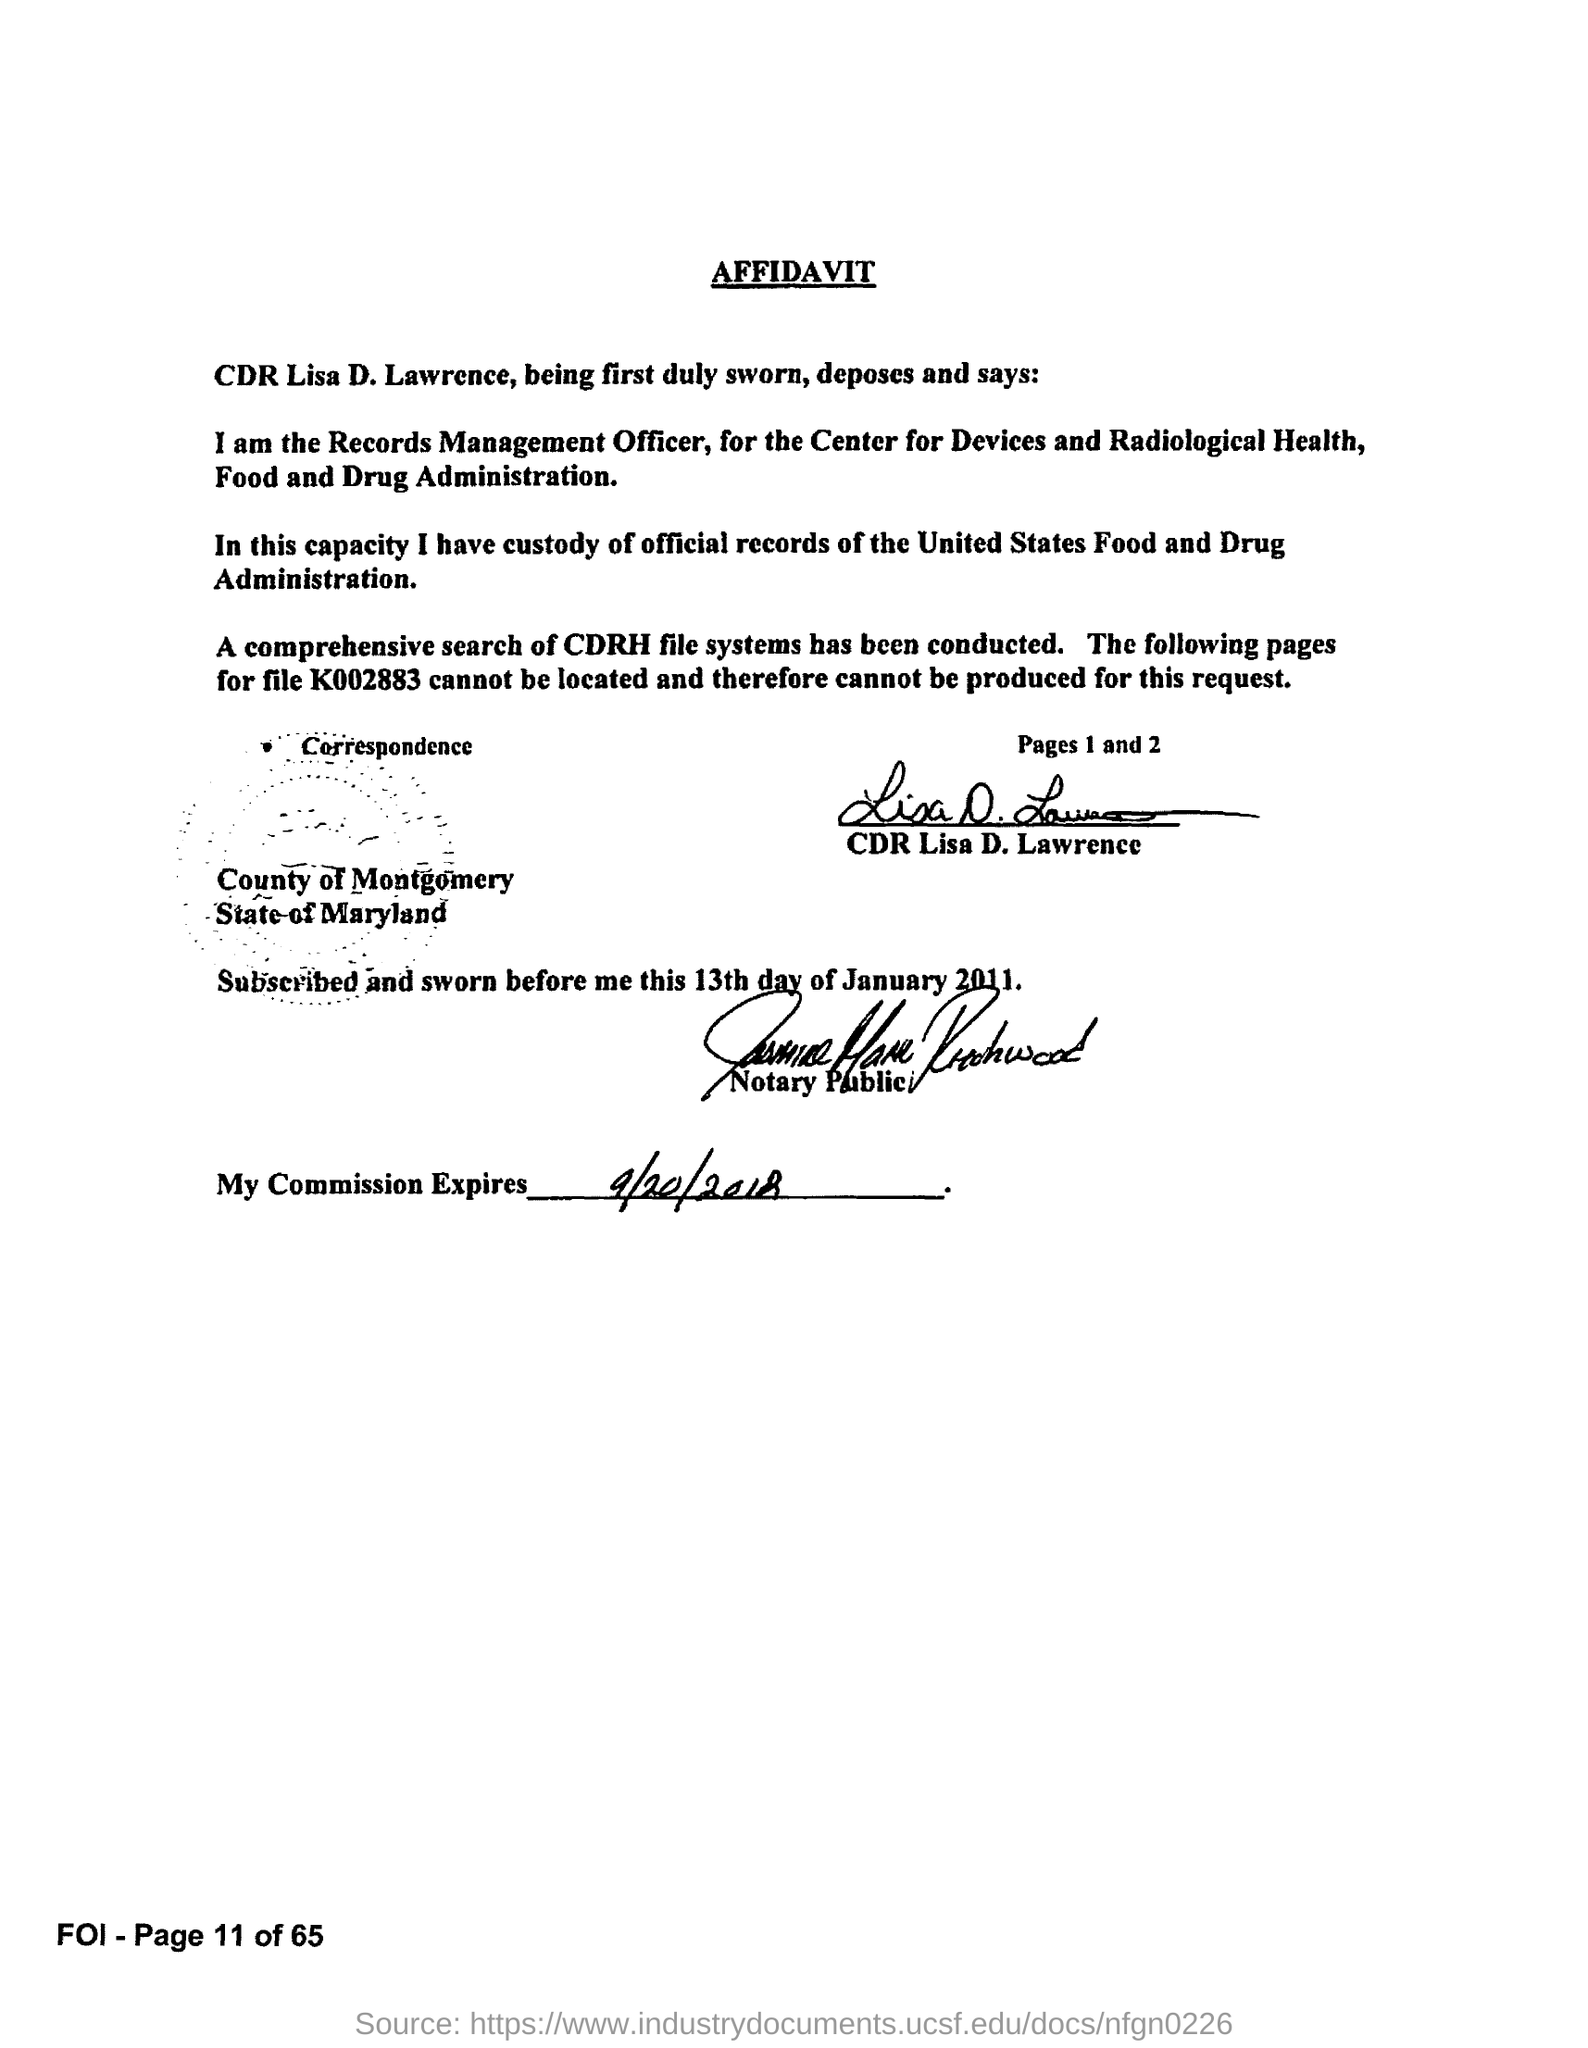Mention a couple of crucial points in this snapshot. CDR Lisa D. Lawrence has signed the affidavit. This is a declaration that this document is an affidavit. 